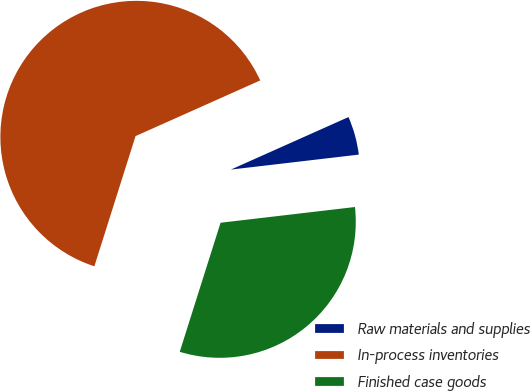Convert chart to OTSL. <chart><loc_0><loc_0><loc_500><loc_500><pie_chart><fcel>Raw materials and supplies<fcel>In-process inventories<fcel>Finished case goods<nl><fcel>4.83%<fcel>63.44%<fcel>31.73%<nl></chart> 